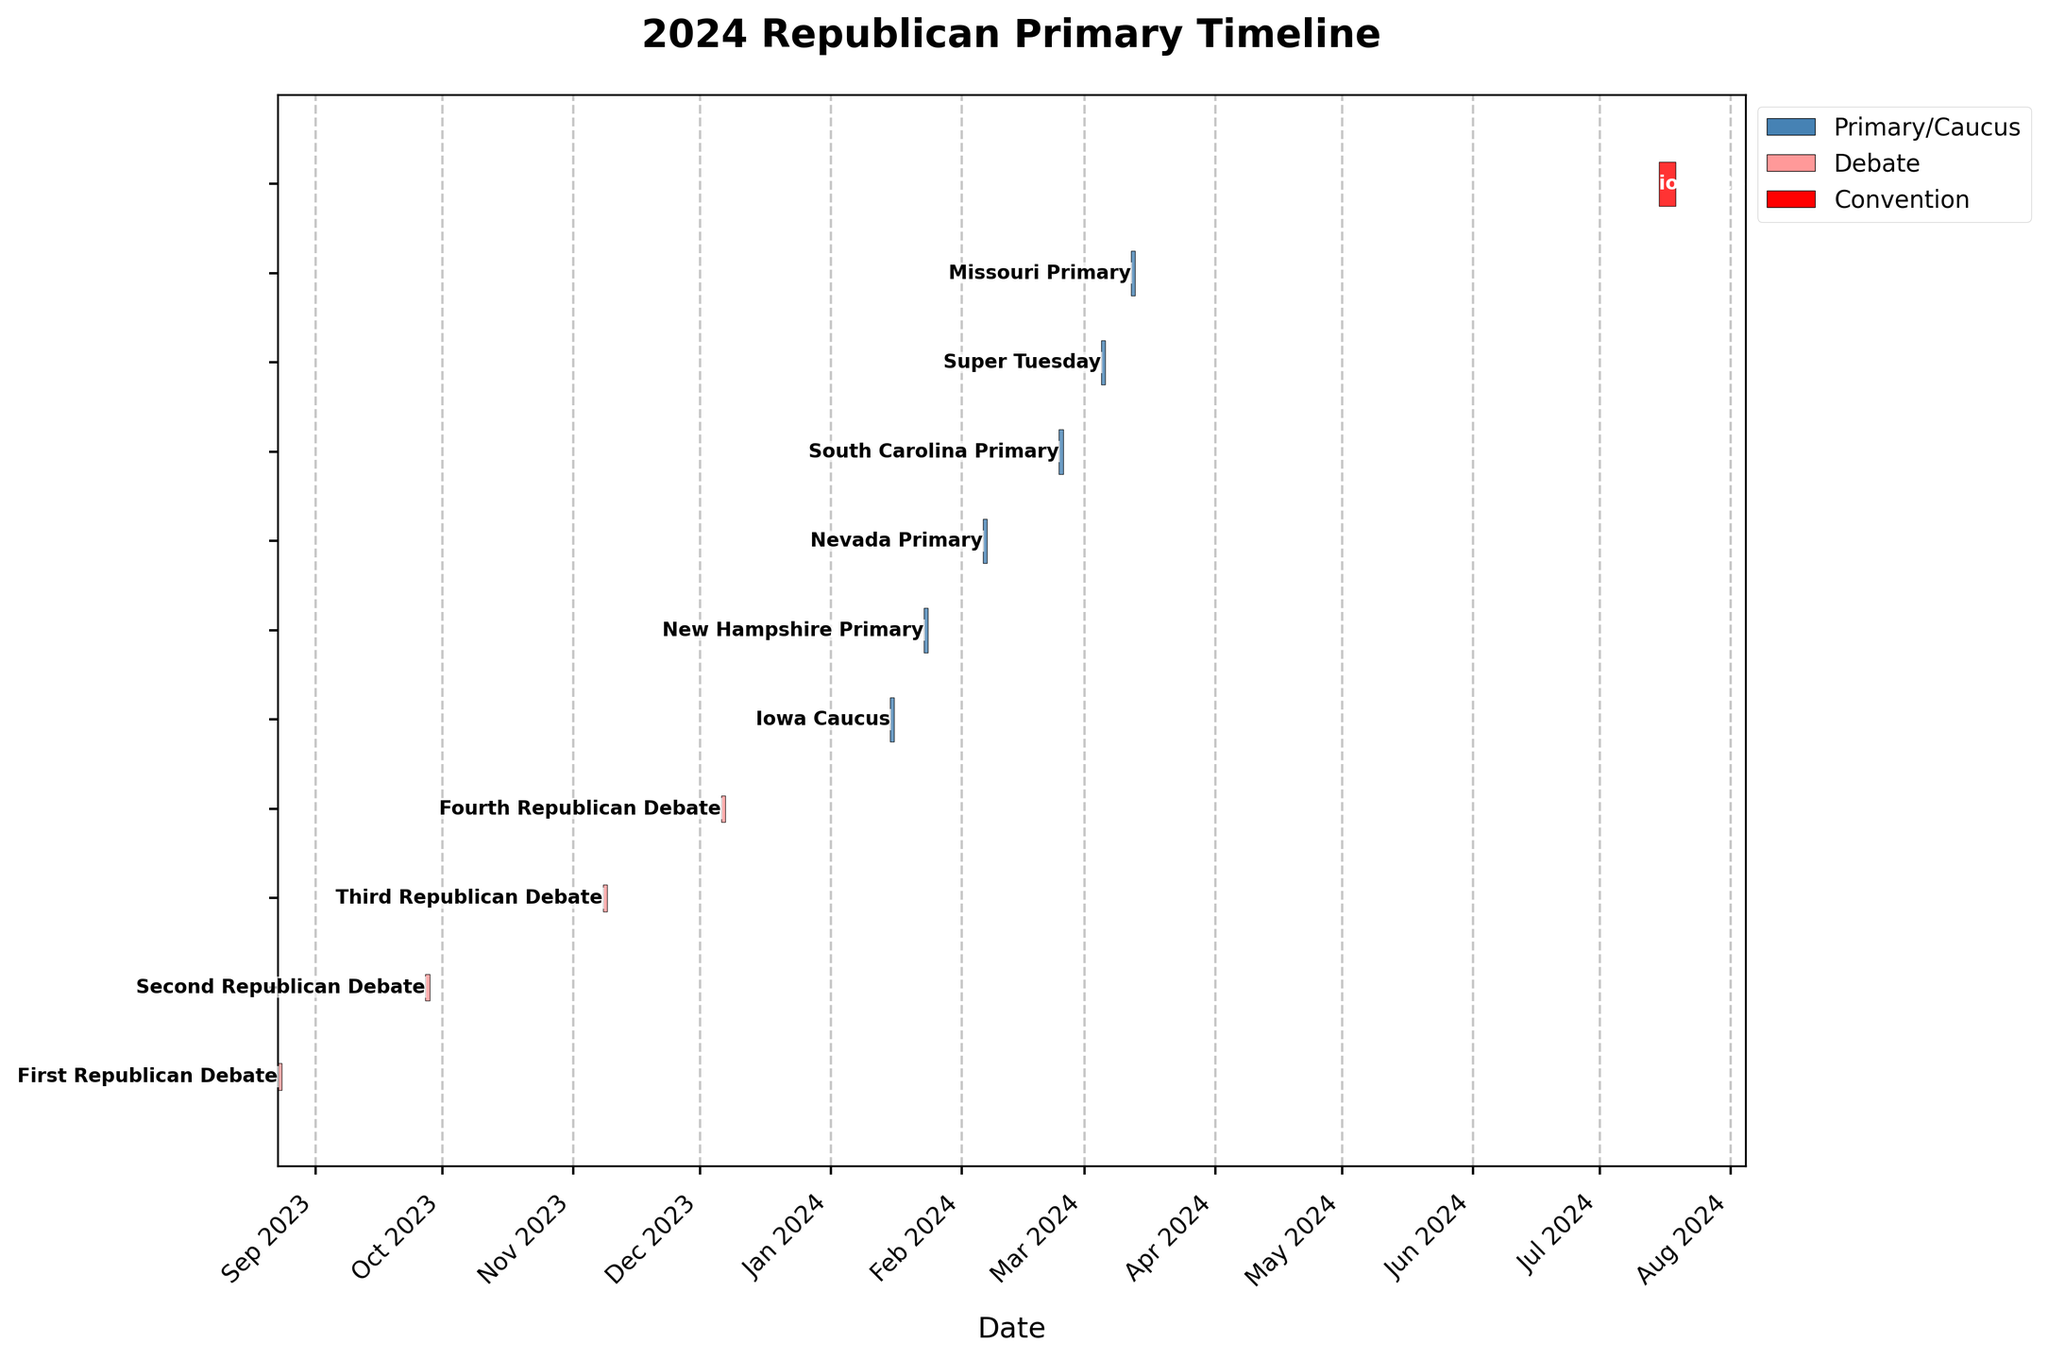When is the Missouri Primary scheduled to take place? According to the Gantt chart, the Missouri Primary is scheduled on a specific date. Identify the blue-colored bar labeled "Missouri Primary" on the chart and read the date.
Answer: 2024-03-12 Which event occurs first: the New Hampshire Primary or the South Carolina Primary? To determine which event occurs first, locate both event bars on the timeline. The New Hampshire Primary appears before the South Carolina Primary.
Answer: New Hampshire Primary How many Republican debates are scheduled before the Nevada Primary? Identify the timeline positions of the Nevada Primary and count the number of debate bars (colored in pink) that are scheduled before it.
Answer: Three How long does the Republican National Convention last? Look at the red bar labeled "Republican National Convention" and calculate the duration between its start and end dates. Subtract the start date from the end date and add one day to include both start and end dates.
Answer: 4 days Do any events overlap in the timeline? Examine the bars on the Gantt chart to see if any overlap. Since each bar is aligned next to each other without overlap, no events overlap.
Answer: No How many events are there in March 2024? Identify and count all the event bars that fall within March 2024. One must check the start and end dates of the bars labeled with the corresponding month of the year.
Answer: Three What is the approximate time gap between the First Republican Debate and the Second Republican Debate? Determine the start dates for both debates from the chart. Calculate the difference in days between 2023-09-27 and 2023-08-23.
Answer: 35 days Which debate is the closest to Super Tuesday? Compare the dates of the debates and find the one closest to the date of Super Tuesday (2024-03-05).
Answer: Fourth Republican Debate What is the latest event listed on the Gantt Chart? Observe the bars and locate the event that appears at the end of the timeline. This event is labeled "Republican National Convention" in red.
Answer: Republican National Convention In which month does the Iowa Caucus occur? Identify the blue-colored bar labeled "Iowa Caucus" and note the month listed for its date.
Answer: January 2024 